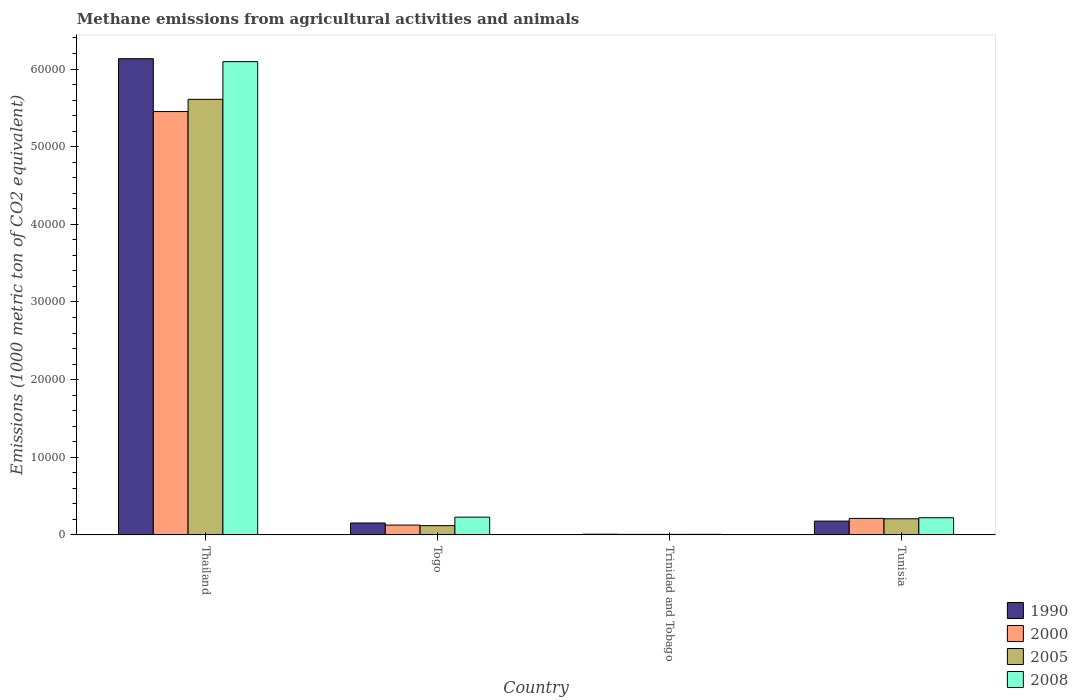How many groups of bars are there?
Keep it short and to the point. 4. Are the number of bars per tick equal to the number of legend labels?
Offer a terse response. Yes. How many bars are there on the 1st tick from the right?
Offer a very short reply. 4. What is the label of the 4th group of bars from the left?
Offer a very short reply. Tunisia. What is the amount of methane emitted in 2008 in Togo?
Provide a succinct answer. 2285.6. Across all countries, what is the maximum amount of methane emitted in 2005?
Provide a short and direct response. 5.61e+04. In which country was the amount of methane emitted in 2005 maximum?
Offer a terse response. Thailand. In which country was the amount of methane emitted in 1990 minimum?
Your answer should be very brief. Trinidad and Tobago. What is the total amount of methane emitted in 1990 in the graph?
Your answer should be very brief. 6.47e+04. What is the difference between the amount of methane emitted in 2000 in Togo and that in Trinidad and Tobago?
Offer a terse response. 1198.2. What is the difference between the amount of methane emitted in 1990 in Tunisia and the amount of methane emitted in 2000 in Trinidad and Tobago?
Provide a short and direct response. 1707.7. What is the average amount of methane emitted in 2000 per country?
Your response must be concise. 1.45e+04. What is the difference between the amount of methane emitted of/in 2005 and amount of methane emitted of/in 1990 in Thailand?
Ensure brevity in your answer.  -5235.2. In how many countries, is the amount of methane emitted in 1990 greater than 10000 1000 metric ton?
Provide a succinct answer. 1. What is the ratio of the amount of methane emitted in 1990 in Togo to that in Tunisia?
Your response must be concise. 0.86. What is the difference between the highest and the second highest amount of methane emitted in 2008?
Give a very brief answer. -75.8. What is the difference between the highest and the lowest amount of methane emitted in 2000?
Your answer should be compact. 5.45e+04. In how many countries, is the amount of methane emitted in 2008 greater than the average amount of methane emitted in 2008 taken over all countries?
Keep it short and to the point. 1. Is the sum of the amount of methane emitted in 2008 in Thailand and Tunisia greater than the maximum amount of methane emitted in 1990 across all countries?
Offer a terse response. Yes. Is it the case that in every country, the sum of the amount of methane emitted in 2008 and amount of methane emitted in 1990 is greater than the sum of amount of methane emitted in 2000 and amount of methane emitted in 2005?
Your answer should be compact. No. Where does the legend appear in the graph?
Offer a very short reply. Bottom right. How many legend labels are there?
Ensure brevity in your answer.  4. What is the title of the graph?
Offer a very short reply. Methane emissions from agricultural activities and animals. What is the label or title of the X-axis?
Provide a succinct answer. Country. What is the label or title of the Y-axis?
Your answer should be very brief. Emissions (1000 metric ton of CO2 equivalent). What is the Emissions (1000 metric ton of CO2 equivalent) of 1990 in Thailand?
Offer a terse response. 6.13e+04. What is the Emissions (1000 metric ton of CO2 equivalent) of 2000 in Thailand?
Your answer should be compact. 5.45e+04. What is the Emissions (1000 metric ton of CO2 equivalent) of 2005 in Thailand?
Provide a succinct answer. 5.61e+04. What is the Emissions (1000 metric ton of CO2 equivalent) of 2008 in Thailand?
Provide a succinct answer. 6.10e+04. What is the Emissions (1000 metric ton of CO2 equivalent) of 1990 in Togo?
Make the answer very short. 1531.1. What is the Emissions (1000 metric ton of CO2 equivalent) of 2000 in Togo?
Provide a succinct answer. 1266.2. What is the Emissions (1000 metric ton of CO2 equivalent) in 2005 in Togo?
Keep it short and to the point. 1193.3. What is the Emissions (1000 metric ton of CO2 equivalent) of 2008 in Togo?
Provide a succinct answer. 2285.6. What is the Emissions (1000 metric ton of CO2 equivalent) of 1990 in Trinidad and Tobago?
Provide a short and direct response. 92.7. What is the Emissions (1000 metric ton of CO2 equivalent) of 2005 in Trinidad and Tobago?
Offer a very short reply. 68.1. What is the Emissions (1000 metric ton of CO2 equivalent) of 2008 in Trinidad and Tobago?
Give a very brief answer. 71. What is the Emissions (1000 metric ton of CO2 equivalent) in 1990 in Tunisia?
Offer a very short reply. 1775.7. What is the Emissions (1000 metric ton of CO2 equivalent) of 2000 in Tunisia?
Your response must be concise. 2123.8. What is the Emissions (1000 metric ton of CO2 equivalent) in 2005 in Tunisia?
Provide a short and direct response. 2076.8. What is the Emissions (1000 metric ton of CO2 equivalent) in 2008 in Tunisia?
Provide a short and direct response. 2209.8. Across all countries, what is the maximum Emissions (1000 metric ton of CO2 equivalent) of 1990?
Your response must be concise. 6.13e+04. Across all countries, what is the maximum Emissions (1000 metric ton of CO2 equivalent) in 2000?
Keep it short and to the point. 5.45e+04. Across all countries, what is the maximum Emissions (1000 metric ton of CO2 equivalent) in 2005?
Offer a terse response. 5.61e+04. Across all countries, what is the maximum Emissions (1000 metric ton of CO2 equivalent) of 2008?
Keep it short and to the point. 6.10e+04. Across all countries, what is the minimum Emissions (1000 metric ton of CO2 equivalent) in 1990?
Provide a short and direct response. 92.7. Across all countries, what is the minimum Emissions (1000 metric ton of CO2 equivalent) in 2000?
Provide a succinct answer. 68. Across all countries, what is the minimum Emissions (1000 metric ton of CO2 equivalent) in 2005?
Your response must be concise. 68.1. What is the total Emissions (1000 metric ton of CO2 equivalent) of 1990 in the graph?
Offer a very short reply. 6.47e+04. What is the total Emissions (1000 metric ton of CO2 equivalent) in 2000 in the graph?
Make the answer very short. 5.80e+04. What is the total Emissions (1000 metric ton of CO2 equivalent) of 2005 in the graph?
Offer a terse response. 5.94e+04. What is the total Emissions (1000 metric ton of CO2 equivalent) in 2008 in the graph?
Offer a terse response. 6.55e+04. What is the difference between the Emissions (1000 metric ton of CO2 equivalent) of 1990 in Thailand and that in Togo?
Keep it short and to the point. 5.98e+04. What is the difference between the Emissions (1000 metric ton of CO2 equivalent) of 2000 in Thailand and that in Togo?
Offer a terse response. 5.33e+04. What is the difference between the Emissions (1000 metric ton of CO2 equivalent) in 2005 in Thailand and that in Togo?
Offer a very short reply. 5.49e+04. What is the difference between the Emissions (1000 metric ton of CO2 equivalent) of 2008 in Thailand and that in Togo?
Ensure brevity in your answer.  5.87e+04. What is the difference between the Emissions (1000 metric ton of CO2 equivalent) of 1990 in Thailand and that in Trinidad and Tobago?
Keep it short and to the point. 6.12e+04. What is the difference between the Emissions (1000 metric ton of CO2 equivalent) in 2000 in Thailand and that in Trinidad and Tobago?
Make the answer very short. 5.45e+04. What is the difference between the Emissions (1000 metric ton of CO2 equivalent) of 2005 in Thailand and that in Trinidad and Tobago?
Your answer should be very brief. 5.60e+04. What is the difference between the Emissions (1000 metric ton of CO2 equivalent) in 2008 in Thailand and that in Trinidad and Tobago?
Ensure brevity in your answer.  6.09e+04. What is the difference between the Emissions (1000 metric ton of CO2 equivalent) in 1990 in Thailand and that in Tunisia?
Offer a terse response. 5.96e+04. What is the difference between the Emissions (1000 metric ton of CO2 equivalent) in 2000 in Thailand and that in Tunisia?
Provide a succinct answer. 5.24e+04. What is the difference between the Emissions (1000 metric ton of CO2 equivalent) in 2005 in Thailand and that in Tunisia?
Give a very brief answer. 5.40e+04. What is the difference between the Emissions (1000 metric ton of CO2 equivalent) in 2008 in Thailand and that in Tunisia?
Ensure brevity in your answer.  5.87e+04. What is the difference between the Emissions (1000 metric ton of CO2 equivalent) of 1990 in Togo and that in Trinidad and Tobago?
Provide a short and direct response. 1438.4. What is the difference between the Emissions (1000 metric ton of CO2 equivalent) in 2000 in Togo and that in Trinidad and Tobago?
Offer a terse response. 1198.2. What is the difference between the Emissions (1000 metric ton of CO2 equivalent) in 2005 in Togo and that in Trinidad and Tobago?
Your answer should be very brief. 1125.2. What is the difference between the Emissions (1000 metric ton of CO2 equivalent) of 2008 in Togo and that in Trinidad and Tobago?
Provide a short and direct response. 2214.6. What is the difference between the Emissions (1000 metric ton of CO2 equivalent) in 1990 in Togo and that in Tunisia?
Offer a very short reply. -244.6. What is the difference between the Emissions (1000 metric ton of CO2 equivalent) of 2000 in Togo and that in Tunisia?
Keep it short and to the point. -857.6. What is the difference between the Emissions (1000 metric ton of CO2 equivalent) of 2005 in Togo and that in Tunisia?
Provide a short and direct response. -883.5. What is the difference between the Emissions (1000 metric ton of CO2 equivalent) of 2008 in Togo and that in Tunisia?
Give a very brief answer. 75.8. What is the difference between the Emissions (1000 metric ton of CO2 equivalent) in 1990 in Trinidad and Tobago and that in Tunisia?
Offer a terse response. -1683. What is the difference between the Emissions (1000 metric ton of CO2 equivalent) in 2000 in Trinidad and Tobago and that in Tunisia?
Offer a terse response. -2055.8. What is the difference between the Emissions (1000 metric ton of CO2 equivalent) in 2005 in Trinidad and Tobago and that in Tunisia?
Make the answer very short. -2008.7. What is the difference between the Emissions (1000 metric ton of CO2 equivalent) of 2008 in Trinidad and Tobago and that in Tunisia?
Provide a short and direct response. -2138.8. What is the difference between the Emissions (1000 metric ton of CO2 equivalent) in 1990 in Thailand and the Emissions (1000 metric ton of CO2 equivalent) in 2000 in Togo?
Provide a succinct answer. 6.01e+04. What is the difference between the Emissions (1000 metric ton of CO2 equivalent) in 1990 in Thailand and the Emissions (1000 metric ton of CO2 equivalent) in 2005 in Togo?
Offer a terse response. 6.01e+04. What is the difference between the Emissions (1000 metric ton of CO2 equivalent) of 1990 in Thailand and the Emissions (1000 metric ton of CO2 equivalent) of 2008 in Togo?
Ensure brevity in your answer.  5.90e+04. What is the difference between the Emissions (1000 metric ton of CO2 equivalent) in 2000 in Thailand and the Emissions (1000 metric ton of CO2 equivalent) in 2005 in Togo?
Ensure brevity in your answer.  5.33e+04. What is the difference between the Emissions (1000 metric ton of CO2 equivalent) of 2000 in Thailand and the Emissions (1000 metric ton of CO2 equivalent) of 2008 in Togo?
Your answer should be very brief. 5.22e+04. What is the difference between the Emissions (1000 metric ton of CO2 equivalent) in 2005 in Thailand and the Emissions (1000 metric ton of CO2 equivalent) in 2008 in Togo?
Provide a succinct answer. 5.38e+04. What is the difference between the Emissions (1000 metric ton of CO2 equivalent) in 1990 in Thailand and the Emissions (1000 metric ton of CO2 equivalent) in 2000 in Trinidad and Tobago?
Offer a terse response. 6.13e+04. What is the difference between the Emissions (1000 metric ton of CO2 equivalent) in 1990 in Thailand and the Emissions (1000 metric ton of CO2 equivalent) in 2005 in Trinidad and Tobago?
Keep it short and to the point. 6.13e+04. What is the difference between the Emissions (1000 metric ton of CO2 equivalent) in 1990 in Thailand and the Emissions (1000 metric ton of CO2 equivalent) in 2008 in Trinidad and Tobago?
Ensure brevity in your answer.  6.13e+04. What is the difference between the Emissions (1000 metric ton of CO2 equivalent) of 2000 in Thailand and the Emissions (1000 metric ton of CO2 equivalent) of 2005 in Trinidad and Tobago?
Offer a terse response. 5.45e+04. What is the difference between the Emissions (1000 metric ton of CO2 equivalent) of 2000 in Thailand and the Emissions (1000 metric ton of CO2 equivalent) of 2008 in Trinidad and Tobago?
Keep it short and to the point. 5.45e+04. What is the difference between the Emissions (1000 metric ton of CO2 equivalent) of 2005 in Thailand and the Emissions (1000 metric ton of CO2 equivalent) of 2008 in Trinidad and Tobago?
Offer a very short reply. 5.60e+04. What is the difference between the Emissions (1000 metric ton of CO2 equivalent) in 1990 in Thailand and the Emissions (1000 metric ton of CO2 equivalent) in 2000 in Tunisia?
Keep it short and to the point. 5.92e+04. What is the difference between the Emissions (1000 metric ton of CO2 equivalent) in 1990 in Thailand and the Emissions (1000 metric ton of CO2 equivalent) in 2005 in Tunisia?
Keep it short and to the point. 5.93e+04. What is the difference between the Emissions (1000 metric ton of CO2 equivalent) of 1990 in Thailand and the Emissions (1000 metric ton of CO2 equivalent) of 2008 in Tunisia?
Your answer should be compact. 5.91e+04. What is the difference between the Emissions (1000 metric ton of CO2 equivalent) of 2000 in Thailand and the Emissions (1000 metric ton of CO2 equivalent) of 2005 in Tunisia?
Give a very brief answer. 5.24e+04. What is the difference between the Emissions (1000 metric ton of CO2 equivalent) in 2000 in Thailand and the Emissions (1000 metric ton of CO2 equivalent) in 2008 in Tunisia?
Your response must be concise. 5.23e+04. What is the difference between the Emissions (1000 metric ton of CO2 equivalent) in 2005 in Thailand and the Emissions (1000 metric ton of CO2 equivalent) in 2008 in Tunisia?
Provide a succinct answer. 5.39e+04. What is the difference between the Emissions (1000 metric ton of CO2 equivalent) in 1990 in Togo and the Emissions (1000 metric ton of CO2 equivalent) in 2000 in Trinidad and Tobago?
Ensure brevity in your answer.  1463.1. What is the difference between the Emissions (1000 metric ton of CO2 equivalent) of 1990 in Togo and the Emissions (1000 metric ton of CO2 equivalent) of 2005 in Trinidad and Tobago?
Provide a succinct answer. 1463. What is the difference between the Emissions (1000 metric ton of CO2 equivalent) of 1990 in Togo and the Emissions (1000 metric ton of CO2 equivalent) of 2008 in Trinidad and Tobago?
Provide a succinct answer. 1460.1. What is the difference between the Emissions (1000 metric ton of CO2 equivalent) of 2000 in Togo and the Emissions (1000 metric ton of CO2 equivalent) of 2005 in Trinidad and Tobago?
Make the answer very short. 1198.1. What is the difference between the Emissions (1000 metric ton of CO2 equivalent) in 2000 in Togo and the Emissions (1000 metric ton of CO2 equivalent) in 2008 in Trinidad and Tobago?
Ensure brevity in your answer.  1195.2. What is the difference between the Emissions (1000 metric ton of CO2 equivalent) in 2005 in Togo and the Emissions (1000 metric ton of CO2 equivalent) in 2008 in Trinidad and Tobago?
Give a very brief answer. 1122.3. What is the difference between the Emissions (1000 metric ton of CO2 equivalent) in 1990 in Togo and the Emissions (1000 metric ton of CO2 equivalent) in 2000 in Tunisia?
Keep it short and to the point. -592.7. What is the difference between the Emissions (1000 metric ton of CO2 equivalent) of 1990 in Togo and the Emissions (1000 metric ton of CO2 equivalent) of 2005 in Tunisia?
Offer a terse response. -545.7. What is the difference between the Emissions (1000 metric ton of CO2 equivalent) in 1990 in Togo and the Emissions (1000 metric ton of CO2 equivalent) in 2008 in Tunisia?
Provide a succinct answer. -678.7. What is the difference between the Emissions (1000 metric ton of CO2 equivalent) of 2000 in Togo and the Emissions (1000 metric ton of CO2 equivalent) of 2005 in Tunisia?
Offer a terse response. -810.6. What is the difference between the Emissions (1000 metric ton of CO2 equivalent) of 2000 in Togo and the Emissions (1000 metric ton of CO2 equivalent) of 2008 in Tunisia?
Give a very brief answer. -943.6. What is the difference between the Emissions (1000 metric ton of CO2 equivalent) in 2005 in Togo and the Emissions (1000 metric ton of CO2 equivalent) in 2008 in Tunisia?
Ensure brevity in your answer.  -1016.5. What is the difference between the Emissions (1000 metric ton of CO2 equivalent) in 1990 in Trinidad and Tobago and the Emissions (1000 metric ton of CO2 equivalent) in 2000 in Tunisia?
Keep it short and to the point. -2031.1. What is the difference between the Emissions (1000 metric ton of CO2 equivalent) in 1990 in Trinidad and Tobago and the Emissions (1000 metric ton of CO2 equivalent) in 2005 in Tunisia?
Your answer should be very brief. -1984.1. What is the difference between the Emissions (1000 metric ton of CO2 equivalent) of 1990 in Trinidad and Tobago and the Emissions (1000 metric ton of CO2 equivalent) of 2008 in Tunisia?
Your answer should be compact. -2117.1. What is the difference between the Emissions (1000 metric ton of CO2 equivalent) in 2000 in Trinidad and Tobago and the Emissions (1000 metric ton of CO2 equivalent) in 2005 in Tunisia?
Your answer should be compact. -2008.8. What is the difference between the Emissions (1000 metric ton of CO2 equivalent) in 2000 in Trinidad and Tobago and the Emissions (1000 metric ton of CO2 equivalent) in 2008 in Tunisia?
Keep it short and to the point. -2141.8. What is the difference between the Emissions (1000 metric ton of CO2 equivalent) in 2005 in Trinidad and Tobago and the Emissions (1000 metric ton of CO2 equivalent) in 2008 in Tunisia?
Give a very brief answer. -2141.7. What is the average Emissions (1000 metric ton of CO2 equivalent) of 1990 per country?
Offer a terse response. 1.62e+04. What is the average Emissions (1000 metric ton of CO2 equivalent) in 2000 per country?
Provide a succinct answer. 1.45e+04. What is the average Emissions (1000 metric ton of CO2 equivalent) of 2005 per country?
Make the answer very short. 1.49e+04. What is the average Emissions (1000 metric ton of CO2 equivalent) in 2008 per country?
Provide a short and direct response. 1.64e+04. What is the difference between the Emissions (1000 metric ton of CO2 equivalent) in 1990 and Emissions (1000 metric ton of CO2 equivalent) in 2000 in Thailand?
Make the answer very short. 6808.4. What is the difference between the Emissions (1000 metric ton of CO2 equivalent) in 1990 and Emissions (1000 metric ton of CO2 equivalent) in 2005 in Thailand?
Keep it short and to the point. 5235.2. What is the difference between the Emissions (1000 metric ton of CO2 equivalent) in 1990 and Emissions (1000 metric ton of CO2 equivalent) in 2008 in Thailand?
Offer a terse response. 381.9. What is the difference between the Emissions (1000 metric ton of CO2 equivalent) of 2000 and Emissions (1000 metric ton of CO2 equivalent) of 2005 in Thailand?
Make the answer very short. -1573.2. What is the difference between the Emissions (1000 metric ton of CO2 equivalent) in 2000 and Emissions (1000 metric ton of CO2 equivalent) in 2008 in Thailand?
Offer a terse response. -6426.5. What is the difference between the Emissions (1000 metric ton of CO2 equivalent) in 2005 and Emissions (1000 metric ton of CO2 equivalent) in 2008 in Thailand?
Your response must be concise. -4853.3. What is the difference between the Emissions (1000 metric ton of CO2 equivalent) of 1990 and Emissions (1000 metric ton of CO2 equivalent) of 2000 in Togo?
Give a very brief answer. 264.9. What is the difference between the Emissions (1000 metric ton of CO2 equivalent) in 1990 and Emissions (1000 metric ton of CO2 equivalent) in 2005 in Togo?
Your answer should be compact. 337.8. What is the difference between the Emissions (1000 metric ton of CO2 equivalent) in 1990 and Emissions (1000 metric ton of CO2 equivalent) in 2008 in Togo?
Offer a terse response. -754.5. What is the difference between the Emissions (1000 metric ton of CO2 equivalent) in 2000 and Emissions (1000 metric ton of CO2 equivalent) in 2005 in Togo?
Offer a very short reply. 72.9. What is the difference between the Emissions (1000 metric ton of CO2 equivalent) of 2000 and Emissions (1000 metric ton of CO2 equivalent) of 2008 in Togo?
Provide a succinct answer. -1019.4. What is the difference between the Emissions (1000 metric ton of CO2 equivalent) of 2005 and Emissions (1000 metric ton of CO2 equivalent) of 2008 in Togo?
Ensure brevity in your answer.  -1092.3. What is the difference between the Emissions (1000 metric ton of CO2 equivalent) of 1990 and Emissions (1000 metric ton of CO2 equivalent) of 2000 in Trinidad and Tobago?
Your answer should be compact. 24.7. What is the difference between the Emissions (1000 metric ton of CO2 equivalent) in 1990 and Emissions (1000 metric ton of CO2 equivalent) in 2005 in Trinidad and Tobago?
Your answer should be very brief. 24.6. What is the difference between the Emissions (1000 metric ton of CO2 equivalent) of 1990 and Emissions (1000 metric ton of CO2 equivalent) of 2008 in Trinidad and Tobago?
Make the answer very short. 21.7. What is the difference between the Emissions (1000 metric ton of CO2 equivalent) in 2005 and Emissions (1000 metric ton of CO2 equivalent) in 2008 in Trinidad and Tobago?
Offer a terse response. -2.9. What is the difference between the Emissions (1000 metric ton of CO2 equivalent) of 1990 and Emissions (1000 metric ton of CO2 equivalent) of 2000 in Tunisia?
Offer a terse response. -348.1. What is the difference between the Emissions (1000 metric ton of CO2 equivalent) in 1990 and Emissions (1000 metric ton of CO2 equivalent) in 2005 in Tunisia?
Your answer should be compact. -301.1. What is the difference between the Emissions (1000 metric ton of CO2 equivalent) of 1990 and Emissions (1000 metric ton of CO2 equivalent) of 2008 in Tunisia?
Provide a short and direct response. -434.1. What is the difference between the Emissions (1000 metric ton of CO2 equivalent) in 2000 and Emissions (1000 metric ton of CO2 equivalent) in 2005 in Tunisia?
Give a very brief answer. 47. What is the difference between the Emissions (1000 metric ton of CO2 equivalent) in 2000 and Emissions (1000 metric ton of CO2 equivalent) in 2008 in Tunisia?
Your answer should be very brief. -86. What is the difference between the Emissions (1000 metric ton of CO2 equivalent) in 2005 and Emissions (1000 metric ton of CO2 equivalent) in 2008 in Tunisia?
Offer a very short reply. -133. What is the ratio of the Emissions (1000 metric ton of CO2 equivalent) of 1990 in Thailand to that in Togo?
Your answer should be very brief. 40.06. What is the ratio of the Emissions (1000 metric ton of CO2 equivalent) in 2000 in Thailand to that in Togo?
Keep it short and to the point. 43.06. What is the ratio of the Emissions (1000 metric ton of CO2 equivalent) of 2005 in Thailand to that in Togo?
Provide a short and direct response. 47.01. What is the ratio of the Emissions (1000 metric ton of CO2 equivalent) of 2008 in Thailand to that in Togo?
Provide a succinct answer. 26.67. What is the ratio of the Emissions (1000 metric ton of CO2 equivalent) of 1990 in Thailand to that in Trinidad and Tobago?
Your answer should be very brief. 661.63. What is the ratio of the Emissions (1000 metric ton of CO2 equivalent) in 2000 in Thailand to that in Trinidad and Tobago?
Provide a short and direct response. 801.84. What is the ratio of the Emissions (1000 metric ton of CO2 equivalent) of 2005 in Thailand to that in Trinidad and Tobago?
Provide a succinct answer. 823.76. What is the ratio of the Emissions (1000 metric ton of CO2 equivalent) of 2008 in Thailand to that in Trinidad and Tobago?
Make the answer very short. 858.47. What is the ratio of the Emissions (1000 metric ton of CO2 equivalent) in 1990 in Thailand to that in Tunisia?
Your response must be concise. 34.54. What is the ratio of the Emissions (1000 metric ton of CO2 equivalent) of 2000 in Thailand to that in Tunisia?
Provide a short and direct response. 25.67. What is the ratio of the Emissions (1000 metric ton of CO2 equivalent) of 2005 in Thailand to that in Tunisia?
Provide a short and direct response. 27.01. What is the ratio of the Emissions (1000 metric ton of CO2 equivalent) in 2008 in Thailand to that in Tunisia?
Offer a terse response. 27.58. What is the ratio of the Emissions (1000 metric ton of CO2 equivalent) in 1990 in Togo to that in Trinidad and Tobago?
Offer a very short reply. 16.52. What is the ratio of the Emissions (1000 metric ton of CO2 equivalent) of 2000 in Togo to that in Trinidad and Tobago?
Offer a very short reply. 18.62. What is the ratio of the Emissions (1000 metric ton of CO2 equivalent) in 2005 in Togo to that in Trinidad and Tobago?
Offer a very short reply. 17.52. What is the ratio of the Emissions (1000 metric ton of CO2 equivalent) in 2008 in Togo to that in Trinidad and Tobago?
Offer a very short reply. 32.19. What is the ratio of the Emissions (1000 metric ton of CO2 equivalent) in 1990 in Togo to that in Tunisia?
Provide a succinct answer. 0.86. What is the ratio of the Emissions (1000 metric ton of CO2 equivalent) in 2000 in Togo to that in Tunisia?
Your response must be concise. 0.6. What is the ratio of the Emissions (1000 metric ton of CO2 equivalent) of 2005 in Togo to that in Tunisia?
Your answer should be very brief. 0.57. What is the ratio of the Emissions (1000 metric ton of CO2 equivalent) of 2008 in Togo to that in Tunisia?
Your answer should be compact. 1.03. What is the ratio of the Emissions (1000 metric ton of CO2 equivalent) of 1990 in Trinidad and Tobago to that in Tunisia?
Make the answer very short. 0.05. What is the ratio of the Emissions (1000 metric ton of CO2 equivalent) in 2000 in Trinidad and Tobago to that in Tunisia?
Keep it short and to the point. 0.03. What is the ratio of the Emissions (1000 metric ton of CO2 equivalent) in 2005 in Trinidad and Tobago to that in Tunisia?
Offer a very short reply. 0.03. What is the ratio of the Emissions (1000 metric ton of CO2 equivalent) of 2008 in Trinidad and Tobago to that in Tunisia?
Offer a very short reply. 0.03. What is the difference between the highest and the second highest Emissions (1000 metric ton of CO2 equivalent) in 1990?
Provide a short and direct response. 5.96e+04. What is the difference between the highest and the second highest Emissions (1000 metric ton of CO2 equivalent) of 2000?
Make the answer very short. 5.24e+04. What is the difference between the highest and the second highest Emissions (1000 metric ton of CO2 equivalent) of 2005?
Your response must be concise. 5.40e+04. What is the difference between the highest and the second highest Emissions (1000 metric ton of CO2 equivalent) of 2008?
Provide a succinct answer. 5.87e+04. What is the difference between the highest and the lowest Emissions (1000 metric ton of CO2 equivalent) in 1990?
Provide a short and direct response. 6.12e+04. What is the difference between the highest and the lowest Emissions (1000 metric ton of CO2 equivalent) of 2000?
Your response must be concise. 5.45e+04. What is the difference between the highest and the lowest Emissions (1000 metric ton of CO2 equivalent) in 2005?
Offer a very short reply. 5.60e+04. What is the difference between the highest and the lowest Emissions (1000 metric ton of CO2 equivalent) of 2008?
Make the answer very short. 6.09e+04. 